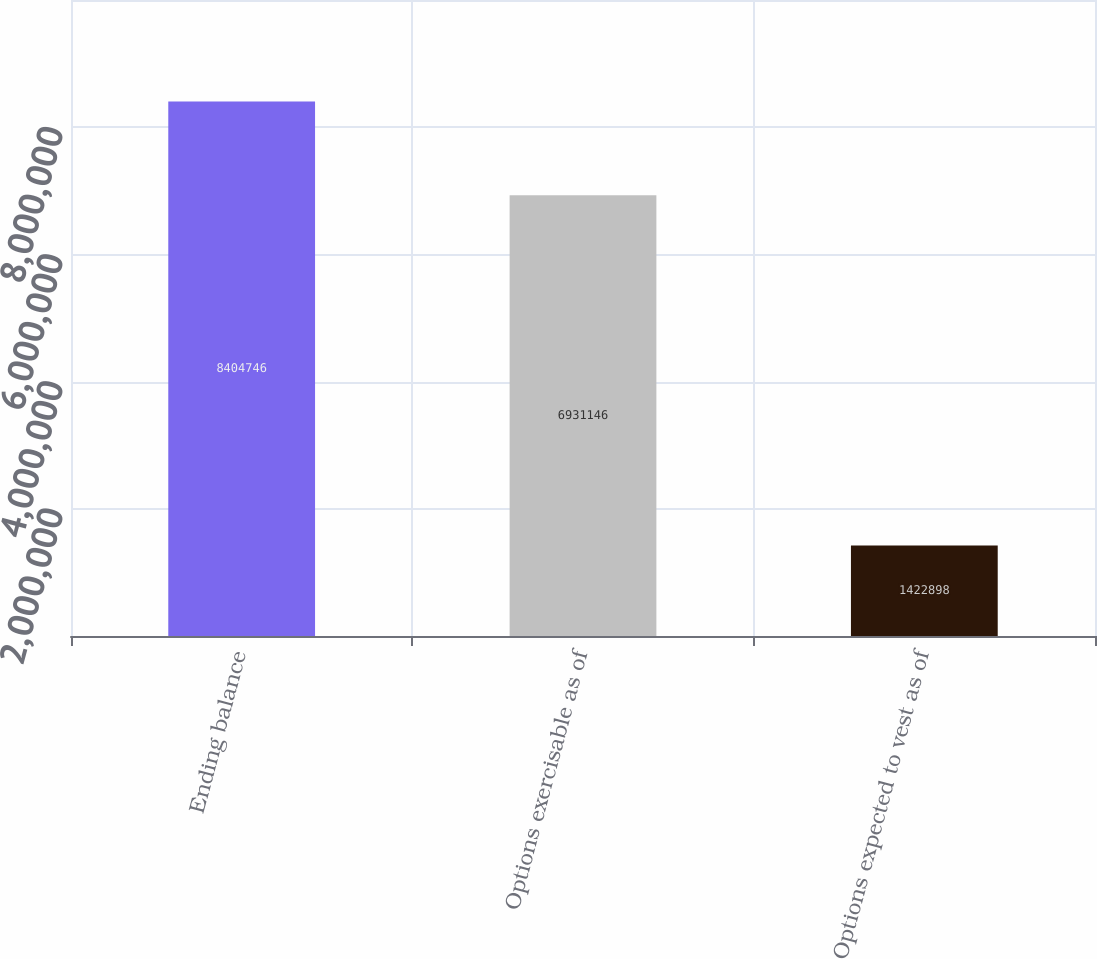<chart> <loc_0><loc_0><loc_500><loc_500><bar_chart><fcel>Ending balance<fcel>Options exercisable as of<fcel>Options expected to vest as of<nl><fcel>8.40475e+06<fcel>6.93115e+06<fcel>1.4229e+06<nl></chart> 